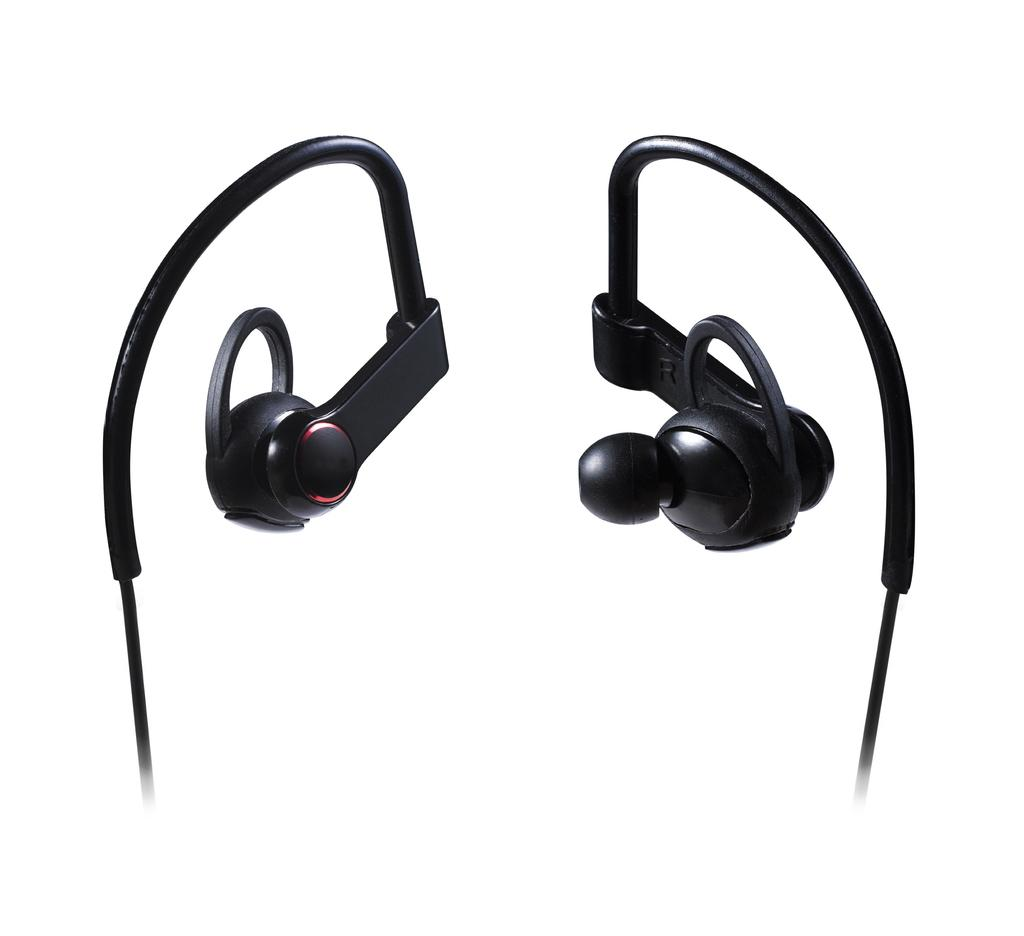What type of audio accessory is present in the image? There are headphones in the image. What might someone use the headphones for? Someone might use the headphones for listening to music, podcasts, or other audio content. How are the headphones connected to a device? The headphones may be connected to a device through a wire or wirelessly via Bluetooth. What type of drink is being served in the headphones in the image? There is no drink being served in the headphones in the image; they are solely an audio accessory. 